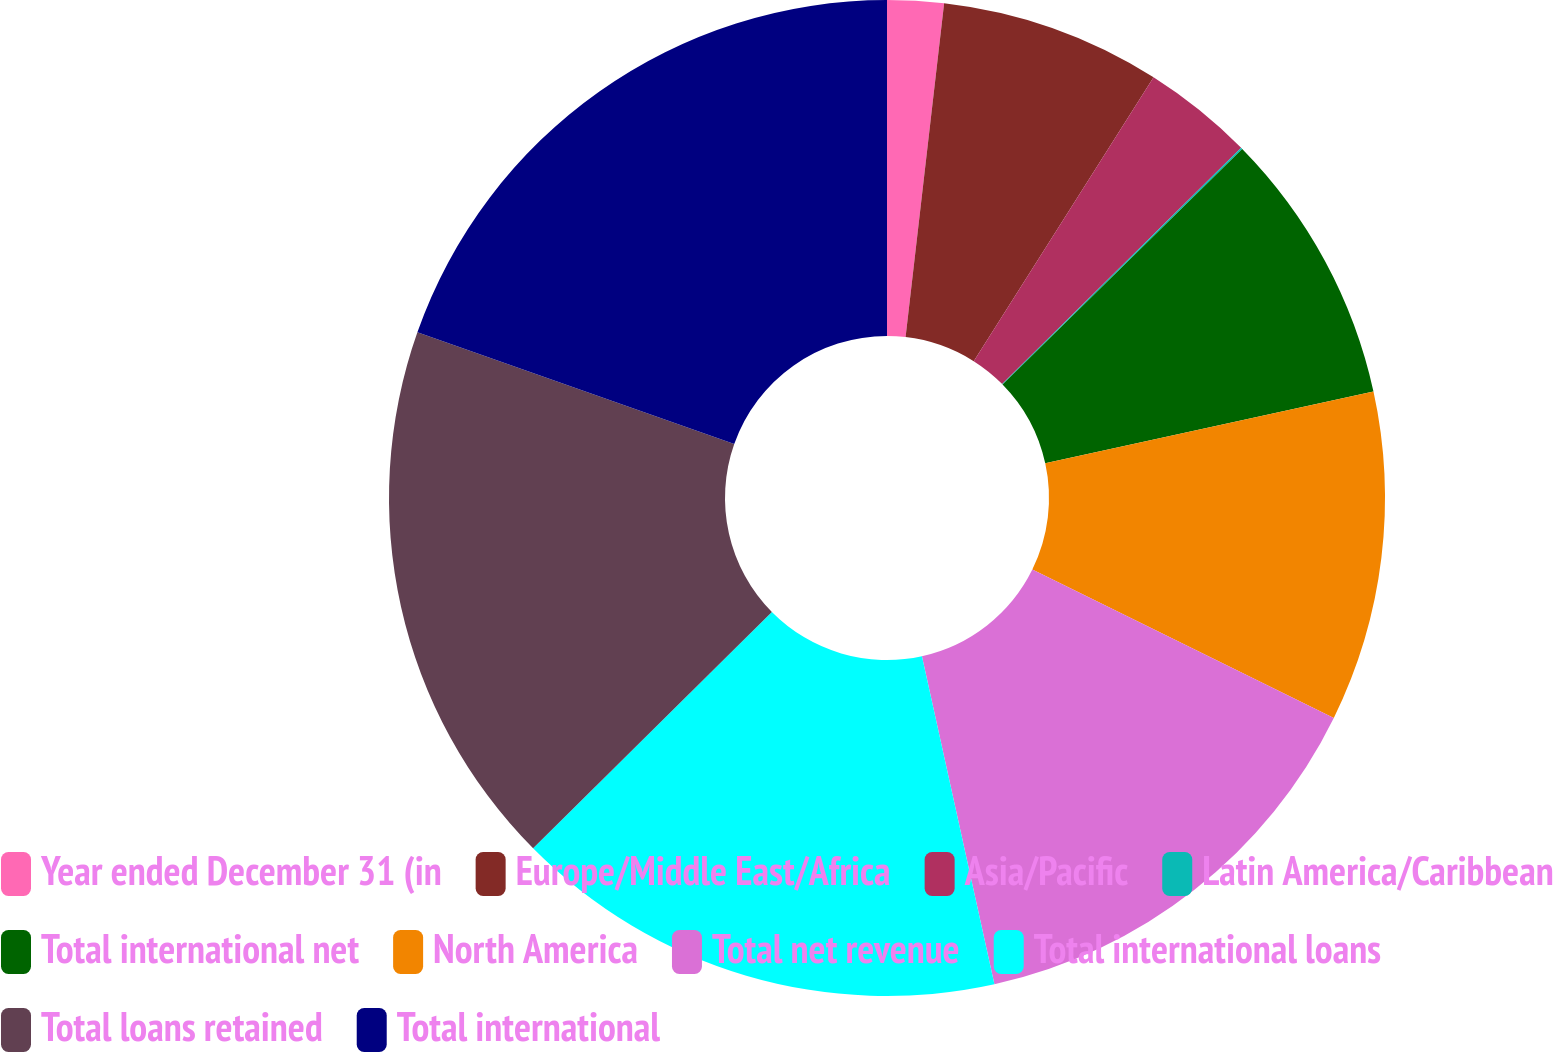<chart> <loc_0><loc_0><loc_500><loc_500><pie_chart><fcel>Year ended December 31 (in<fcel>Europe/Middle East/Africa<fcel>Asia/Pacific<fcel>Latin America/Caribbean<fcel>Total international net<fcel>North America<fcel>Total net revenue<fcel>Total international loans<fcel>Total loans retained<fcel>Total international<nl><fcel>1.83%<fcel>7.16%<fcel>3.6%<fcel>0.05%<fcel>8.93%<fcel>10.71%<fcel>14.26%<fcel>16.04%<fcel>17.82%<fcel>19.6%<nl></chart> 